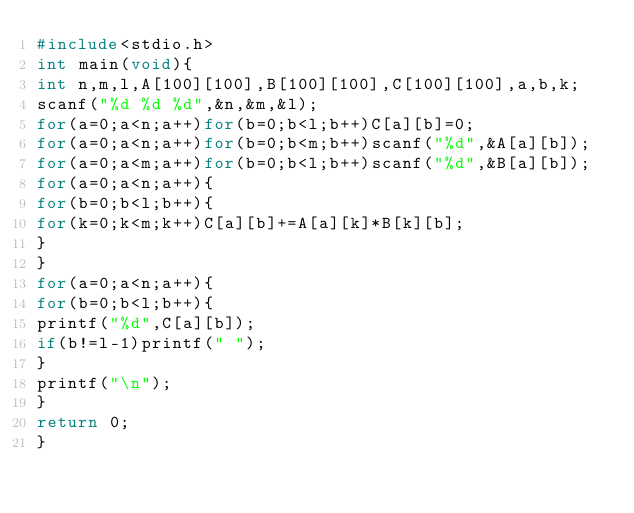Convert code to text. <code><loc_0><loc_0><loc_500><loc_500><_C_>#include<stdio.h>
int main(void){
int n,m,l,A[100][100],B[100][100],C[100][100],a,b,k;
scanf("%d %d %d",&n,&m,&l);
for(a=0;a<n;a++)for(b=0;b<l;b++)C[a][b]=0;
for(a=0;a<n;a++)for(b=0;b<m;b++)scanf("%d",&A[a][b]);
for(a=0;a<m;a++)for(b=0;b<l;b++)scanf("%d",&B[a][b]);
for(a=0;a<n;a++){
for(b=0;b<l;b++){
for(k=0;k<m;k++)C[a][b]+=A[a][k]*B[k][b];
}
}
for(a=0;a<n;a++){
for(b=0;b<l;b++){
printf("%d",C[a][b]);
if(b!=l-1)printf(" ");
}
printf("\n");
}
return 0;
}
</code> 